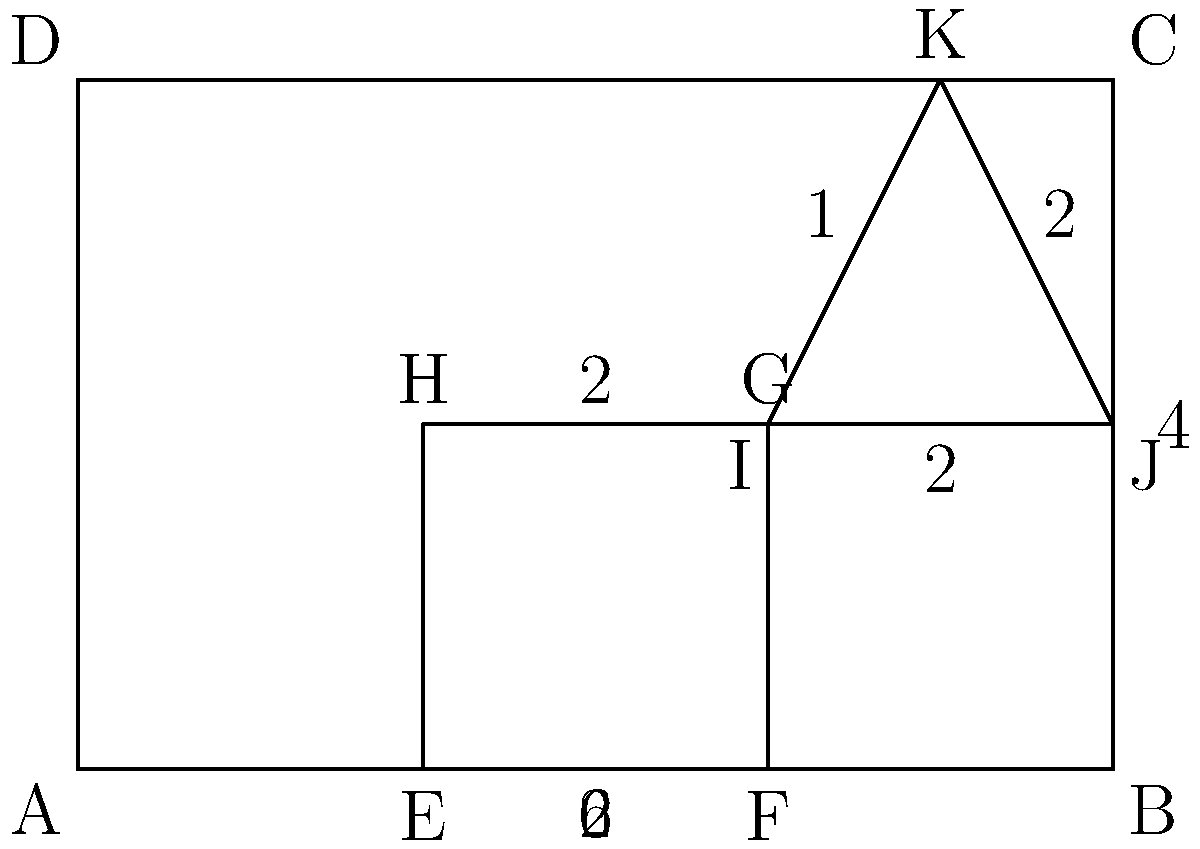In the context of developing a virtual classroom layout tool, you're tasked with calculating the total area of the complex shape shown above. The shape is composed of a large rectangle ABCD, a smaller rectangle EFGH, and a right triangle IJK. Given that the dimensions are in meters, what is the total area of the shaded region in square meters? Let's break this down step-by-step:

1) First, calculate the area of the large rectangle ABCD:
   $A_{ABCD} = 6 \times 4 = 24$ m²

2) Next, calculate the area of the smaller rectangle EFGH:
   $A_{EFGH} = 2 \times 2 = 4$ m²

3) Calculate the area of the right triangle IJK:
   $A_{IJK} = \frac{1}{2} \times 2 \times 2 = 2$ m²

4) The shaded area is the area of ABCD minus the areas of EFGH and IJK:
   $A_{shaded} = A_{ABCD} - (A_{EFGH} + A_{IJK})$
   $A_{shaded} = 24 - (4 + 2) = 24 - 6 = 18$ m²

Therefore, the total area of the shaded region is 18 square meters.

This problem demonstrates the importance of spatial reasoning and geometric calculations in designing virtual learning environments, which is crucial in education technology and future school management.
Answer: 18 m² 